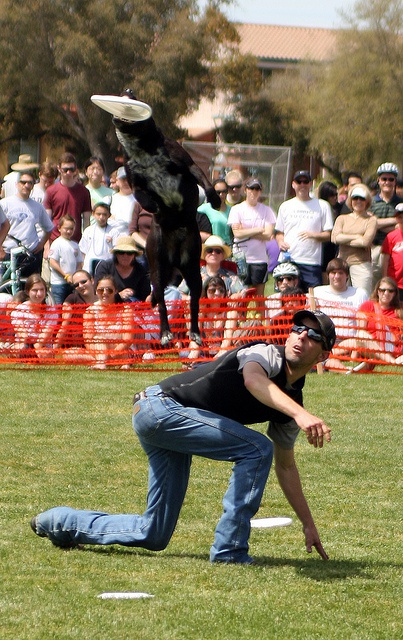Describe the objects in this image and their specific colors. I can see people in olive, black, white, gray, and brown tones, people in olive, black, navy, maroon, and gray tones, dog in olive, black, gray, and maroon tones, people in gray, white, black, and darkgray tones, and people in gray, red, and salmon tones in this image. 